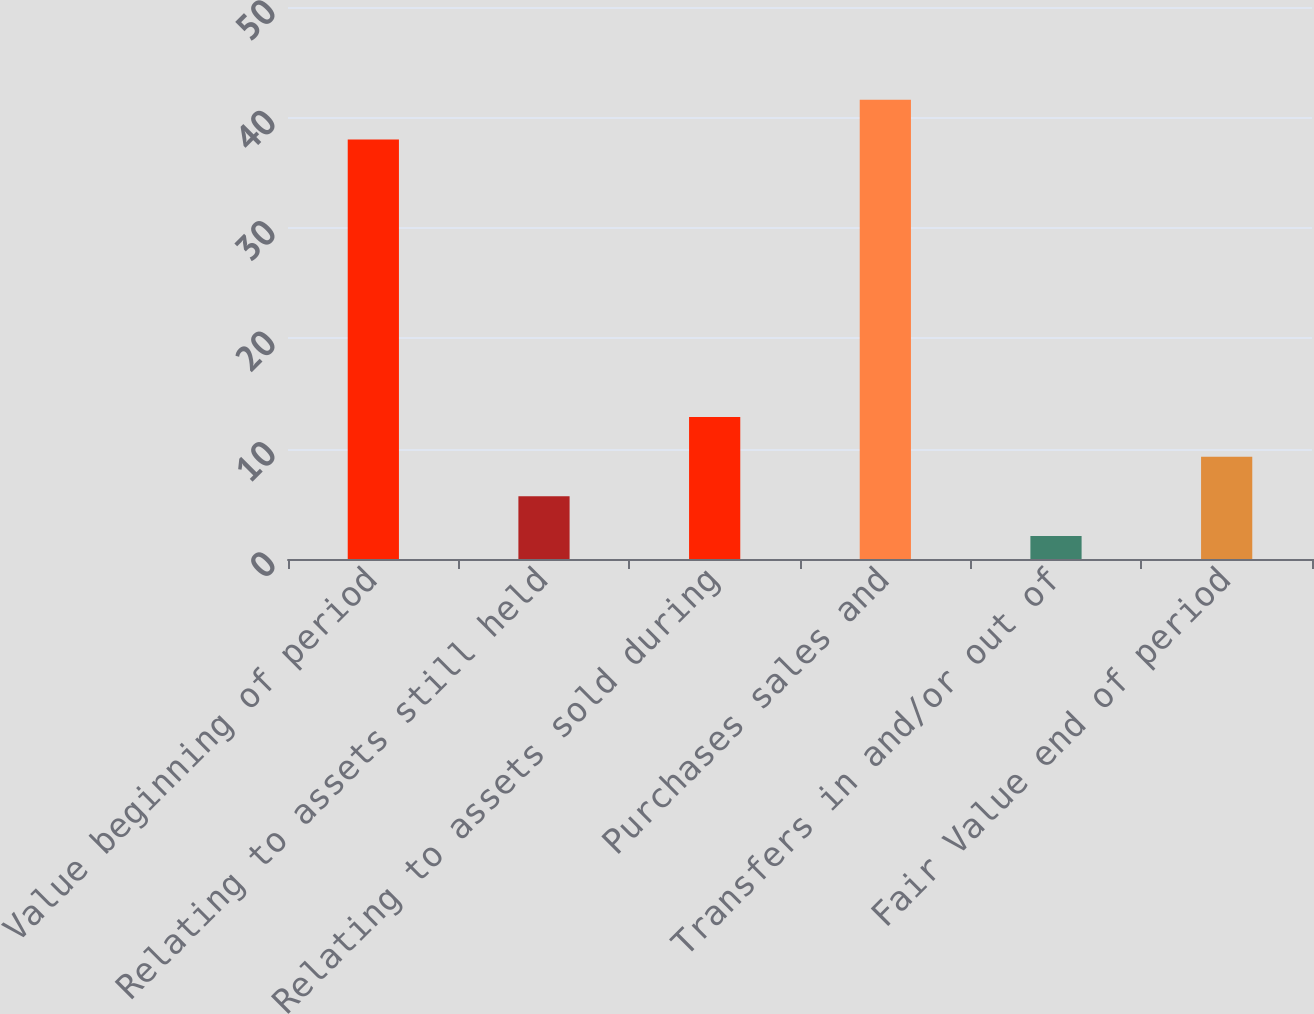<chart> <loc_0><loc_0><loc_500><loc_500><bar_chart><fcel>Fair Value beginning of period<fcel>Relating to assets still held<fcel>Relating to assets sold during<fcel>Purchases sales and<fcel>Transfers in and/or out of<fcel>Fair Value end of period<nl><fcel>38<fcel>5.68<fcel>12.86<fcel>41.59<fcel>2.09<fcel>9.27<nl></chart> 